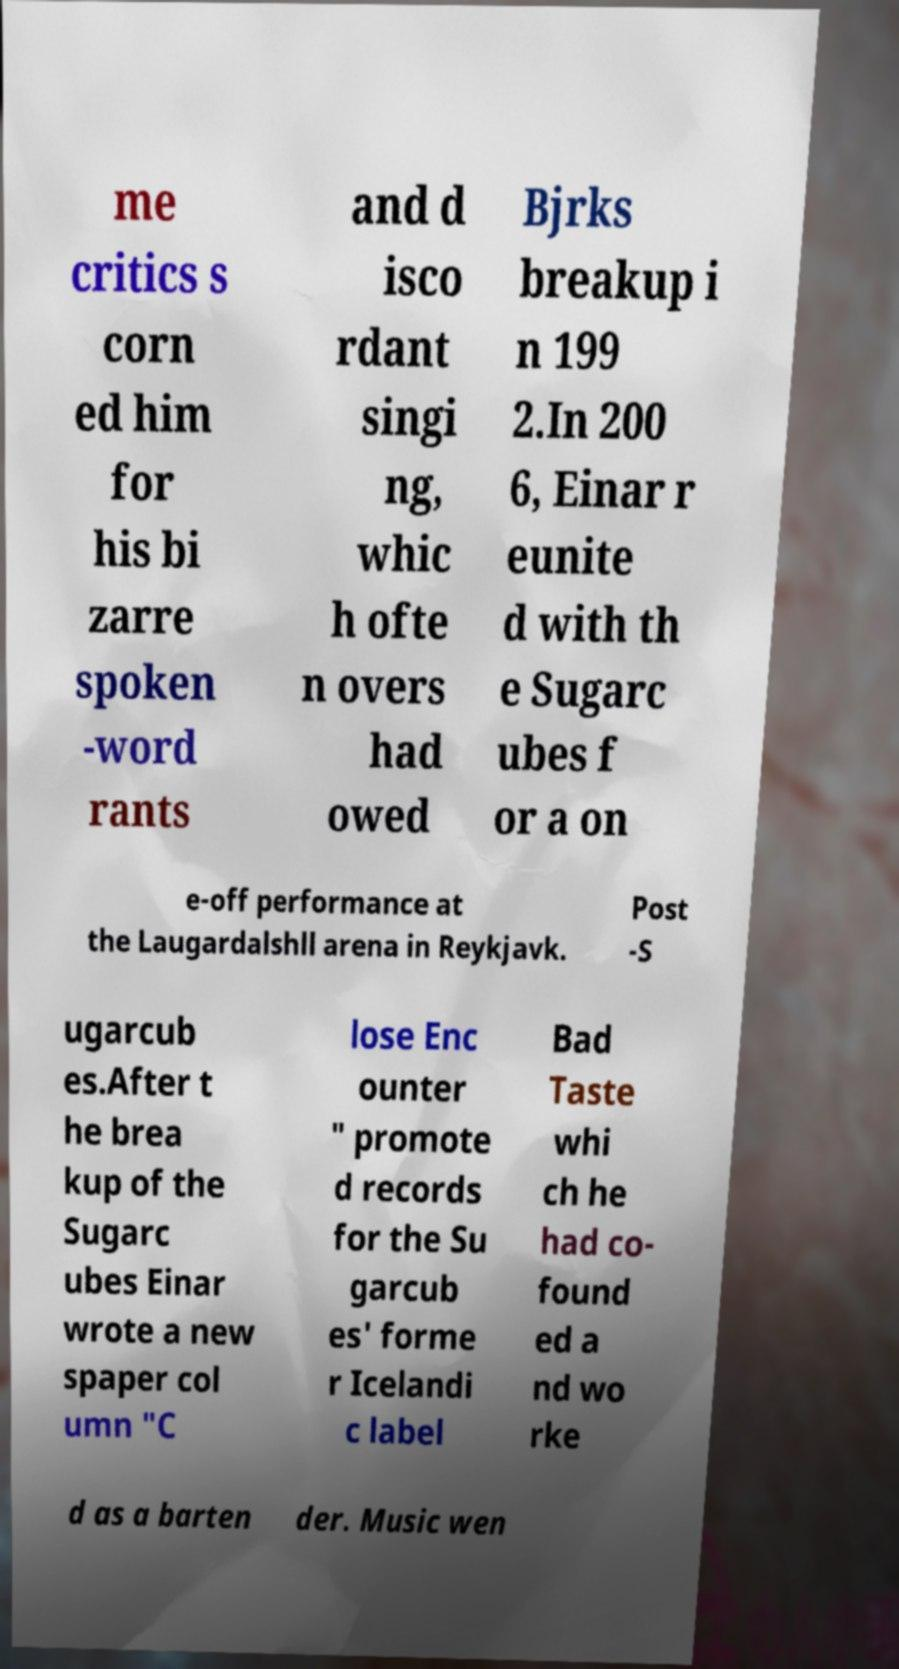There's text embedded in this image that I need extracted. Can you transcribe it verbatim? me critics s corn ed him for his bi zarre spoken -word rants and d isco rdant singi ng, whic h ofte n overs had owed Bjrks breakup i n 199 2.In 200 6, Einar r eunite d with th e Sugarc ubes f or a on e-off performance at the Laugardalshll arena in Reykjavk. Post -S ugarcub es.After t he brea kup of the Sugarc ubes Einar wrote a new spaper col umn "C lose Enc ounter " promote d records for the Su garcub es' forme r Icelandi c label Bad Taste whi ch he had co- found ed a nd wo rke d as a barten der. Music wen 